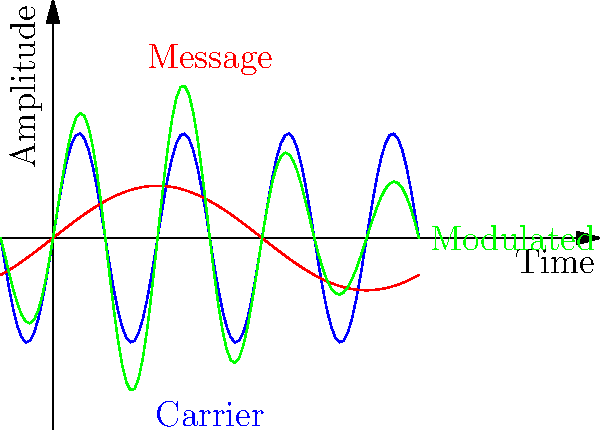In the graph above, which represents an amplitude modulated (AM) radio signal, what is the modulation index of the signal? Assume the carrier wave has an amplitude of 1. To find the modulation index, we need to follow these steps:

1. Identify the message signal (red curve) and its amplitude.
2. Identify the carrier signal (blue curve) and its amplitude.
3. Use the formula for modulation index: $m = \frac{A_m}{A_c}$

Where:
$m$ is the modulation index
$A_m$ is the amplitude of the message signal
$A_c$ is the amplitude of the carrier signal

From the graph:
1. The message signal (red curve) has an amplitude of 0.5.
2. The carrier signal (blue curve) has an amplitude of 1 (given in the question).

Therefore:

$m = \frac{A_m}{A_c} = \frac{0.5}{1} = 0.5$

The modulation index is 0.5 or 50%.
Answer: 0.5 